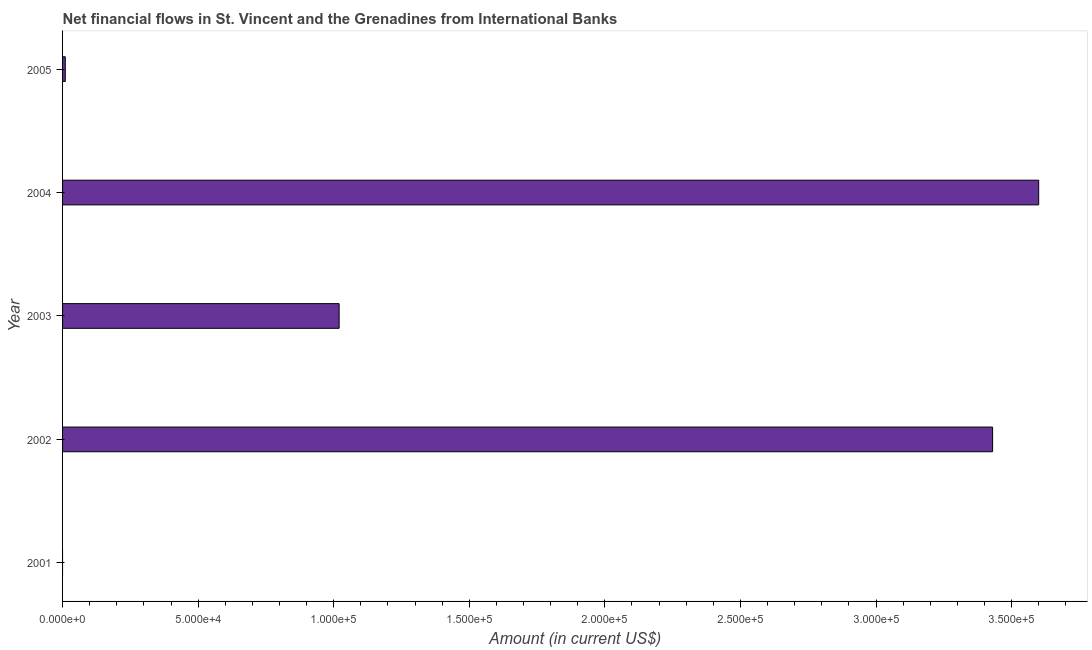Does the graph contain grids?
Give a very brief answer. No. What is the title of the graph?
Ensure brevity in your answer.  Net financial flows in St. Vincent and the Grenadines from International Banks. What is the net financial flows from ibrd in 2003?
Ensure brevity in your answer.  1.02e+05. Across all years, what is the maximum net financial flows from ibrd?
Provide a succinct answer. 3.60e+05. What is the sum of the net financial flows from ibrd?
Offer a very short reply. 8.06e+05. What is the difference between the net financial flows from ibrd in 2004 and 2005?
Offer a very short reply. 3.59e+05. What is the average net financial flows from ibrd per year?
Your response must be concise. 1.61e+05. What is the median net financial flows from ibrd?
Make the answer very short. 1.02e+05. In how many years, is the net financial flows from ibrd greater than 360000 US$?
Offer a terse response. 0. What is the ratio of the net financial flows from ibrd in 2002 to that in 2004?
Your response must be concise. 0.95. Is the difference between the net financial flows from ibrd in 2003 and 2004 greater than the difference between any two years?
Give a very brief answer. No. What is the difference between the highest and the second highest net financial flows from ibrd?
Keep it short and to the point. 1.70e+04. What is the difference between the highest and the lowest net financial flows from ibrd?
Keep it short and to the point. 3.60e+05. How many bars are there?
Provide a succinct answer. 4. How many years are there in the graph?
Provide a short and direct response. 5. What is the Amount (in current US$) of 2001?
Ensure brevity in your answer.  0. What is the Amount (in current US$) of 2002?
Your answer should be very brief. 3.43e+05. What is the Amount (in current US$) of 2003?
Your response must be concise. 1.02e+05. What is the Amount (in current US$) in 2005?
Offer a very short reply. 1000. What is the difference between the Amount (in current US$) in 2002 and 2003?
Provide a short and direct response. 2.41e+05. What is the difference between the Amount (in current US$) in 2002 and 2004?
Offer a very short reply. -1.70e+04. What is the difference between the Amount (in current US$) in 2002 and 2005?
Offer a terse response. 3.42e+05. What is the difference between the Amount (in current US$) in 2003 and 2004?
Your answer should be compact. -2.58e+05. What is the difference between the Amount (in current US$) in 2003 and 2005?
Ensure brevity in your answer.  1.01e+05. What is the difference between the Amount (in current US$) in 2004 and 2005?
Provide a short and direct response. 3.59e+05. What is the ratio of the Amount (in current US$) in 2002 to that in 2003?
Offer a terse response. 3.36. What is the ratio of the Amount (in current US$) in 2002 to that in 2004?
Your answer should be compact. 0.95. What is the ratio of the Amount (in current US$) in 2002 to that in 2005?
Your response must be concise. 343. What is the ratio of the Amount (in current US$) in 2003 to that in 2004?
Provide a short and direct response. 0.28. What is the ratio of the Amount (in current US$) in 2003 to that in 2005?
Make the answer very short. 102. What is the ratio of the Amount (in current US$) in 2004 to that in 2005?
Provide a succinct answer. 360. 